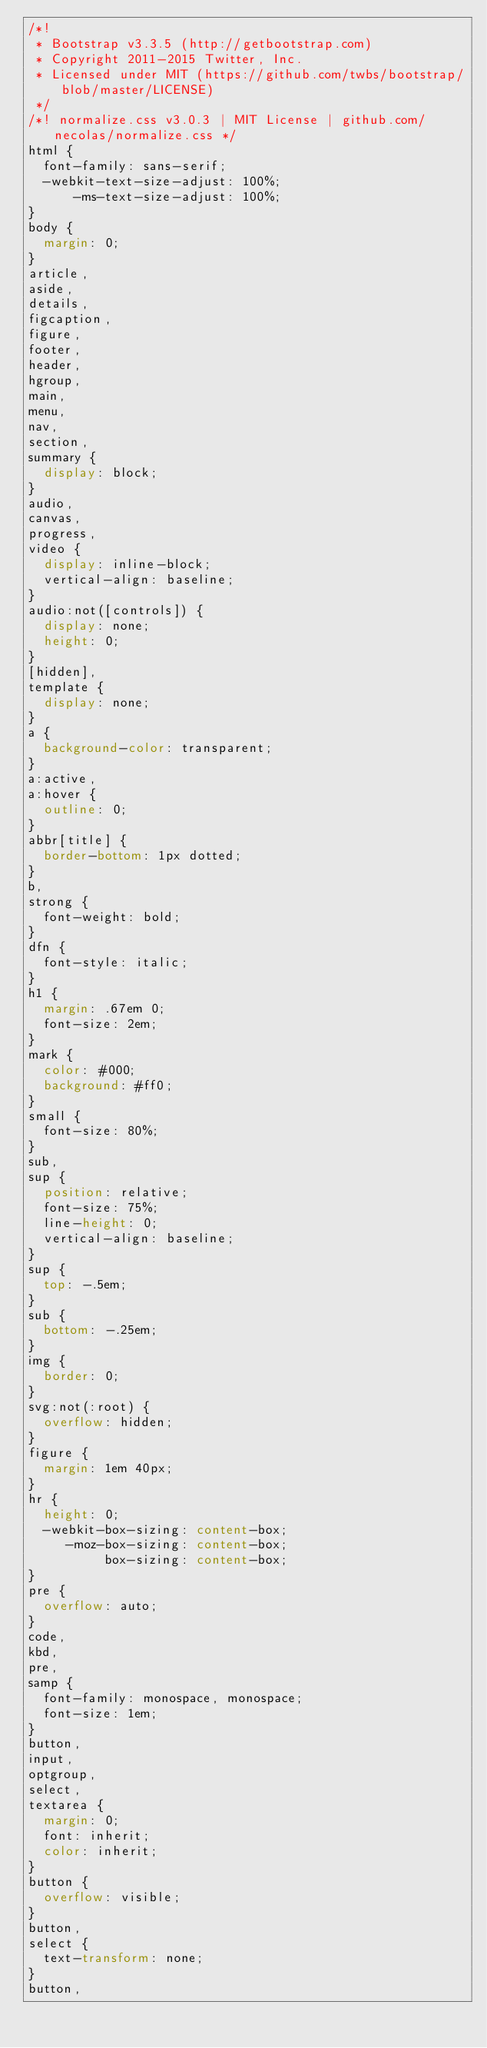<code> <loc_0><loc_0><loc_500><loc_500><_CSS_>/*!
 * Bootstrap v3.3.5 (http://getbootstrap.com)
 * Copyright 2011-2015 Twitter, Inc.
 * Licensed under MIT (https://github.com/twbs/bootstrap/blob/master/LICENSE)
 */
/*! normalize.css v3.0.3 | MIT License | github.com/necolas/normalize.css */
html {
  font-family: sans-serif;
  -webkit-text-size-adjust: 100%;
      -ms-text-size-adjust: 100%;
}
body {
  margin: 0;
}
article,
aside,
details,
figcaption,
figure,
footer,
header,
hgroup,
main,
menu,
nav,
section,
summary {
  display: block;
}
audio,
canvas,
progress,
video {
  display: inline-block;
  vertical-align: baseline;
}
audio:not([controls]) {
  display: none;
  height: 0;
}
[hidden],
template {
  display: none;
}
a {
  background-color: transparent;
}
a:active,
a:hover {
  outline: 0;
}
abbr[title] {
  border-bottom: 1px dotted;
}
b,
strong {
  font-weight: bold;
}
dfn {
  font-style: italic;
}
h1 {
  margin: .67em 0;
  font-size: 2em;
}
mark {
  color: #000;
  background: #ff0;
}
small {
  font-size: 80%;
}
sub,
sup {
  position: relative;
  font-size: 75%;
  line-height: 0;
  vertical-align: baseline;
}
sup {
  top: -.5em;
}
sub {
  bottom: -.25em;
}
img {
  border: 0;
}
svg:not(:root) {
  overflow: hidden;
}
figure {
  margin: 1em 40px;
}
hr {
  height: 0;
  -webkit-box-sizing: content-box;
     -moz-box-sizing: content-box;
          box-sizing: content-box;
}
pre {
  overflow: auto;
}
code,
kbd,
pre,
samp {
  font-family: monospace, monospace;
  font-size: 1em;
}
button,
input,
optgroup,
select,
textarea {
  margin: 0;
  font: inherit;
  color: inherit;
}
button {
  overflow: visible;
}
button,
select {
  text-transform: none;
}
button,</code> 